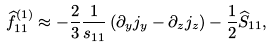<formula> <loc_0><loc_0><loc_500><loc_500>\widehat { f } ^ { ( 1 ) } _ { 1 1 } \approx - \frac { 2 } { 3 } \frac { 1 } { s _ { 1 1 } } \left ( \partial _ { y } j _ { y } - \partial _ { z } j _ { z } \right ) - \frac { 1 } { 2 } \widehat { S } _ { 1 1 } ,</formula> 